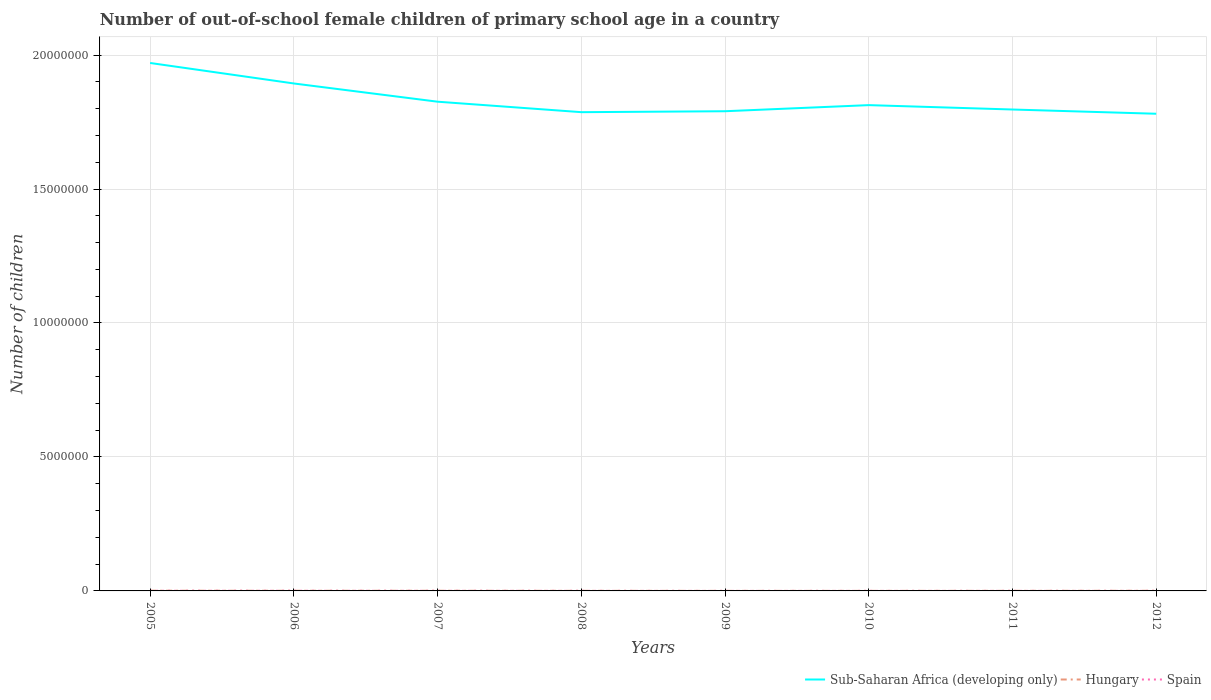How many different coloured lines are there?
Offer a very short reply. 3. Does the line corresponding to Sub-Saharan Africa (developing only) intersect with the line corresponding to Spain?
Your response must be concise. No. Is the number of lines equal to the number of legend labels?
Ensure brevity in your answer.  Yes. Across all years, what is the maximum number of out-of-school female children in Hungary?
Your answer should be very brief. 2098. In which year was the number of out-of-school female children in Spain maximum?
Your answer should be compact. 2009. What is the total number of out-of-school female children in Sub-Saharan Africa (developing only) in the graph?
Offer a very short reply. 1.28e+05. What is the difference between the highest and the second highest number of out-of-school female children in Spain?
Provide a succinct answer. 4768. What is the difference between the highest and the lowest number of out-of-school female children in Sub-Saharan Africa (developing only)?
Keep it short and to the point. 2. Is the number of out-of-school female children in Spain strictly greater than the number of out-of-school female children in Hungary over the years?
Keep it short and to the point. Yes. What is the difference between two consecutive major ticks on the Y-axis?
Your answer should be very brief. 5.00e+06. Are the values on the major ticks of Y-axis written in scientific E-notation?
Provide a succinct answer. No. Does the graph contain grids?
Your response must be concise. Yes. How are the legend labels stacked?
Offer a terse response. Horizontal. What is the title of the graph?
Provide a short and direct response. Number of out-of-school female children of primary school age in a country. What is the label or title of the X-axis?
Offer a very short reply. Years. What is the label or title of the Y-axis?
Provide a short and direct response. Number of children. What is the Number of children in Sub-Saharan Africa (developing only) in 2005?
Ensure brevity in your answer.  1.97e+07. What is the Number of children of Hungary in 2005?
Your response must be concise. 8210. What is the Number of children in Spain in 2005?
Offer a terse response. 5658. What is the Number of children in Sub-Saharan Africa (developing only) in 2006?
Give a very brief answer. 1.89e+07. What is the Number of children of Hungary in 2006?
Make the answer very short. 6465. What is the Number of children in Spain in 2006?
Give a very brief answer. 5814. What is the Number of children in Sub-Saharan Africa (developing only) in 2007?
Make the answer very short. 1.83e+07. What is the Number of children in Hungary in 2007?
Your answer should be very brief. 6589. What is the Number of children of Spain in 2007?
Your answer should be compact. 4183. What is the Number of children in Sub-Saharan Africa (developing only) in 2008?
Offer a terse response. 1.79e+07. What is the Number of children in Hungary in 2008?
Ensure brevity in your answer.  3879. What is the Number of children of Spain in 2008?
Your response must be concise. 2914. What is the Number of children in Sub-Saharan Africa (developing only) in 2009?
Provide a succinct answer. 1.79e+07. What is the Number of children in Hungary in 2009?
Your answer should be compact. 2098. What is the Number of children in Spain in 2009?
Your response must be concise. 1046. What is the Number of children in Sub-Saharan Africa (developing only) in 2010?
Give a very brief answer. 1.81e+07. What is the Number of children in Hungary in 2010?
Give a very brief answer. 2276. What is the Number of children in Spain in 2010?
Provide a short and direct response. 2010. What is the Number of children of Sub-Saharan Africa (developing only) in 2011?
Make the answer very short. 1.80e+07. What is the Number of children in Hungary in 2011?
Give a very brief answer. 3832. What is the Number of children of Spain in 2011?
Keep it short and to the point. 2020. What is the Number of children of Sub-Saharan Africa (developing only) in 2012?
Your response must be concise. 1.78e+07. What is the Number of children of Hungary in 2012?
Make the answer very short. 5886. What is the Number of children in Spain in 2012?
Provide a succinct answer. 1822. Across all years, what is the maximum Number of children of Sub-Saharan Africa (developing only)?
Offer a very short reply. 1.97e+07. Across all years, what is the maximum Number of children in Hungary?
Provide a succinct answer. 8210. Across all years, what is the maximum Number of children in Spain?
Offer a terse response. 5814. Across all years, what is the minimum Number of children in Sub-Saharan Africa (developing only)?
Offer a very short reply. 1.78e+07. Across all years, what is the minimum Number of children of Hungary?
Your answer should be compact. 2098. Across all years, what is the minimum Number of children of Spain?
Your answer should be compact. 1046. What is the total Number of children in Sub-Saharan Africa (developing only) in the graph?
Offer a terse response. 1.47e+08. What is the total Number of children in Hungary in the graph?
Your answer should be compact. 3.92e+04. What is the total Number of children in Spain in the graph?
Provide a succinct answer. 2.55e+04. What is the difference between the Number of children of Sub-Saharan Africa (developing only) in 2005 and that in 2006?
Give a very brief answer. 7.65e+05. What is the difference between the Number of children in Hungary in 2005 and that in 2006?
Your answer should be very brief. 1745. What is the difference between the Number of children in Spain in 2005 and that in 2006?
Make the answer very short. -156. What is the difference between the Number of children in Sub-Saharan Africa (developing only) in 2005 and that in 2007?
Provide a short and direct response. 1.45e+06. What is the difference between the Number of children in Hungary in 2005 and that in 2007?
Keep it short and to the point. 1621. What is the difference between the Number of children in Spain in 2005 and that in 2007?
Provide a succinct answer. 1475. What is the difference between the Number of children of Sub-Saharan Africa (developing only) in 2005 and that in 2008?
Give a very brief answer. 1.84e+06. What is the difference between the Number of children of Hungary in 2005 and that in 2008?
Your response must be concise. 4331. What is the difference between the Number of children in Spain in 2005 and that in 2008?
Your answer should be compact. 2744. What is the difference between the Number of children of Sub-Saharan Africa (developing only) in 2005 and that in 2009?
Your answer should be very brief. 1.80e+06. What is the difference between the Number of children of Hungary in 2005 and that in 2009?
Give a very brief answer. 6112. What is the difference between the Number of children of Spain in 2005 and that in 2009?
Make the answer very short. 4612. What is the difference between the Number of children of Sub-Saharan Africa (developing only) in 2005 and that in 2010?
Offer a very short reply. 1.57e+06. What is the difference between the Number of children in Hungary in 2005 and that in 2010?
Ensure brevity in your answer.  5934. What is the difference between the Number of children in Spain in 2005 and that in 2010?
Keep it short and to the point. 3648. What is the difference between the Number of children in Sub-Saharan Africa (developing only) in 2005 and that in 2011?
Offer a terse response. 1.74e+06. What is the difference between the Number of children of Hungary in 2005 and that in 2011?
Make the answer very short. 4378. What is the difference between the Number of children of Spain in 2005 and that in 2011?
Your response must be concise. 3638. What is the difference between the Number of children of Sub-Saharan Africa (developing only) in 2005 and that in 2012?
Offer a very short reply. 1.90e+06. What is the difference between the Number of children of Hungary in 2005 and that in 2012?
Offer a very short reply. 2324. What is the difference between the Number of children of Spain in 2005 and that in 2012?
Make the answer very short. 3836. What is the difference between the Number of children in Sub-Saharan Africa (developing only) in 2006 and that in 2007?
Offer a very short reply. 6.80e+05. What is the difference between the Number of children of Hungary in 2006 and that in 2007?
Keep it short and to the point. -124. What is the difference between the Number of children of Spain in 2006 and that in 2007?
Ensure brevity in your answer.  1631. What is the difference between the Number of children of Sub-Saharan Africa (developing only) in 2006 and that in 2008?
Give a very brief answer. 1.07e+06. What is the difference between the Number of children of Hungary in 2006 and that in 2008?
Your answer should be very brief. 2586. What is the difference between the Number of children of Spain in 2006 and that in 2008?
Give a very brief answer. 2900. What is the difference between the Number of children in Sub-Saharan Africa (developing only) in 2006 and that in 2009?
Offer a very short reply. 1.04e+06. What is the difference between the Number of children in Hungary in 2006 and that in 2009?
Provide a short and direct response. 4367. What is the difference between the Number of children in Spain in 2006 and that in 2009?
Your answer should be very brief. 4768. What is the difference between the Number of children of Sub-Saharan Africa (developing only) in 2006 and that in 2010?
Offer a terse response. 8.08e+05. What is the difference between the Number of children of Hungary in 2006 and that in 2010?
Provide a succinct answer. 4189. What is the difference between the Number of children of Spain in 2006 and that in 2010?
Provide a short and direct response. 3804. What is the difference between the Number of children of Sub-Saharan Africa (developing only) in 2006 and that in 2011?
Your answer should be very brief. 9.72e+05. What is the difference between the Number of children in Hungary in 2006 and that in 2011?
Ensure brevity in your answer.  2633. What is the difference between the Number of children of Spain in 2006 and that in 2011?
Your response must be concise. 3794. What is the difference between the Number of children in Sub-Saharan Africa (developing only) in 2006 and that in 2012?
Your response must be concise. 1.13e+06. What is the difference between the Number of children in Hungary in 2006 and that in 2012?
Keep it short and to the point. 579. What is the difference between the Number of children of Spain in 2006 and that in 2012?
Make the answer very short. 3992. What is the difference between the Number of children of Sub-Saharan Africa (developing only) in 2007 and that in 2008?
Your answer should be compact. 3.91e+05. What is the difference between the Number of children of Hungary in 2007 and that in 2008?
Give a very brief answer. 2710. What is the difference between the Number of children of Spain in 2007 and that in 2008?
Offer a very short reply. 1269. What is the difference between the Number of children of Sub-Saharan Africa (developing only) in 2007 and that in 2009?
Provide a succinct answer. 3.56e+05. What is the difference between the Number of children of Hungary in 2007 and that in 2009?
Your answer should be very brief. 4491. What is the difference between the Number of children of Spain in 2007 and that in 2009?
Give a very brief answer. 3137. What is the difference between the Number of children in Sub-Saharan Africa (developing only) in 2007 and that in 2010?
Keep it short and to the point. 1.28e+05. What is the difference between the Number of children of Hungary in 2007 and that in 2010?
Ensure brevity in your answer.  4313. What is the difference between the Number of children of Spain in 2007 and that in 2010?
Offer a very short reply. 2173. What is the difference between the Number of children in Sub-Saharan Africa (developing only) in 2007 and that in 2011?
Your answer should be compact. 2.92e+05. What is the difference between the Number of children in Hungary in 2007 and that in 2011?
Give a very brief answer. 2757. What is the difference between the Number of children in Spain in 2007 and that in 2011?
Keep it short and to the point. 2163. What is the difference between the Number of children in Sub-Saharan Africa (developing only) in 2007 and that in 2012?
Provide a succinct answer. 4.50e+05. What is the difference between the Number of children of Hungary in 2007 and that in 2012?
Provide a succinct answer. 703. What is the difference between the Number of children of Spain in 2007 and that in 2012?
Keep it short and to the point. 2361. What is the difference between the Number of children of Sub-Saharan Africa (developing only) in 2008 and that in 2009?
Ensure brevity in your answer.  -3.47e+04. What is the difference between the Number of children of Hungary in 2008 and that in 2009?
Offer a terse response. 1781. What is the difference between the Number of children of Spain in 2008 and that in 2009?
Keep it short and to the point. 1868. What is the difference between the Number of children of Sub-Saharan Africa (developing only) in 2008 and that in 2010?
Offer a terse response. -2.63e+05. What is the difference between the Number of children in Hungary in 2008 and that in 2010?
Your answer should be very brief. 1603. What is the difference between the Number of children of Spain in 2008 and that in 2010?
Your answer should be compact. 904. What is the difference between the Number of children in Sub-Saharan Africa (developing only) in 2008 and that in 2011?
Make the answer very short. -9.92e+04. What is the difference between the Number of children of Hungary in 2008 and that in 2011?
Ensure brevity in your answer.  47. What is the difference between the Number of children in Spain in 2008 and that in 2011?
Provide a succinct answer. 894. What is the difference between the Number of children of Sub-Saharan Africa (developing only) in 2008 and that in 2012?
Provide a succinct answer. 5.90e+04. What is the difference between the Number of children of Hungary in 2008 and that in 2012?
Provide a short and direct response. -2007. What is the difference between the Number of children of Spain in 2008 and that in 2012?
Your answer should be compact. 1092. What is the difference between the Number of children in Sub-Saharan Africa (developing only) in 2009 and that in 2010?
Give a very brief answer. -2.28e+05. What is the difference between the Number of children of Hungary in 2009 and that in 2010?
Your response must be concise. -178. What is the difference between the Number of children of Spain in 2009 and that in 2010?
Provide a short and direct response. -964. What is the difference between the Number of children of Sub-Saharan Africa (developing only) in 2009 and that in 2011?
Provide a short and direct response. -6.44e+04. What is the difference between the Number of children of Hungary in 2009 and that in 2011?
Keep it short and to the point. -1734. What is the difference between the Number of children of Spain in 2009 and that in 2011?
Your answer should be compact. -974. What is the difference between the Number of children of Sub-Saharan Africa (developing only) in 2009 and that in 2012?
Make the answer very short. 9.38e+04. What is the difference between the Number of children of Hungary in 2009 and that in 2012?
Offer a terse response. -3788. What is the difference between the Number of children in Spain in 2009 and that in 2012?
Provide a succinct answer. -776. What is the difference between the Number of children in Sub-Saharan Africa (developing only) in 2010 and that in 2011?
Keep it short and to the point. 1.64e+05. What is the difference between the Number of children in Hungary in 2010 and that in 2011?
Give a very brief answer. -1556. What is the difference between the Number of children in Spain in 2010 and that in 2011?
Offer a very short reply. -10. What is the difference between the Number of children in Sub-Saharan Africa (developing only) in 2010 and that in 2012?
Your answer should be very brief. 3.22e+05. What is the difference between the Number of children of Hungary in 2010 and that in 2012?
Your answer should be very brief. -3610. What is the difference between the Number of children of Spain in 2010 and that in 2012?
Give a very brief answer. 188. What is the difference between the Number of children in Sub-Saharan Africa (developing only) in 2011 and that in 2012?
Offer a very short reply. 1.58e+05. What is the difference between the Number of children in Hungary in 2011 and that in 2012?
Your answer should be compact. -2054. What is the difference between the Number of children of Spain in 2011 and that in 2012?
Your answer should be compact. 198. What is the difference between the Number of children in Sub-Saharan Africa (developing only) in 2005 and the Number of children in Hungary in 2006?
Provide a succinct answer. 1.97e+07. What is the difference between the Number of children in Sub-Saharan Africa (developing only) in 2005 and the Number of children in Spain in 2006?
Keep it short and to the point. 1.97e+07. What is the difference between the Number of children in Hungary in 2005 and the Number of children in Spain in 2006?
Provide a short and direct response. 2396. What is the difference between the Number of children of Sub-Saharan Africa (developing only) in 2005 and the Number of children of Hungary in 2007?
Ensure brevity in your answer.  1.97e+07. What is the difference between the Number of children in Sub-Saharan Africa (developing only) in 2005 and the Number of children in Spain in 2007?
Your answer should be very brief. 1.97e+07. What is the difference between the Number of children in Hungary in 2005 and the Number of children in Spain in 2007?
Offer a very short reply. 4027. What is the difference between the Number of children of Sub-Saharan Africa (developing only) in 2005 and the Number of children of Hungary in 2008?
Provide a succinct answer. 1.97e+07. What is the difference between the Number of children in Sub-Saharan Africa (developing only) in 2005 and the Number of children in Spain in 2008?
Provide a short and direct response. 1.97e+07. What is the difference between the Number of children of Hungary in 2005 and the Number of children of Spain in 2008?
Provide a short and direct response. 5296. What is the difference between the Number of children in Sub-Saharan Africa (developing only) in 2005 and the Number of children in Hungary in 2009?
Ensure brevity in your answer.  1.97e+07. What is the difference between the Number of children of Sub-Saharan Africa (developing only) in 2005 and the Number of children of Spain in 2009?
Give a very brief answer. 1.97e+07. What is the difference between the Number of children of Hungary in 2005 and the Number of children of Spain in 2009?
Offer a very short reply. 7164. What is the difference between the Number of children of Sub-Saharan Africa (developing only) in 2005 and the Number of children of Hungary in 2010?
Provide a succinct answer. 1.97e+07. What is the difference between the Number of children of Sub-Saharan Africa (developing only) in 2005 and the Number of children of Spain in 2010?
Your answer should be compact. 1.97e+07. What is the difference between the Number of children of Hungary in 2005 and the Number of children of Spain in 2010?
Provide a short and direct response. 6200. What is the difference between the Number of children of Sub-Saharan Africa (developing only) in 2005 and the Number of children of Hungary in 2011?
Your answer should be compact. 1.97e+07. What is the difference between the Number of children of Sub-Saharan Africa (developing only) in 2005 and the Number of children of Spain in 2011?
Keep it short and to the point. 1.97e+07. What is the difference between the Number of children in Hungary in 2005 and the Number of children in Spain in 2011?
Your answer should be very brief. 6190. What is the difference between the Number of children of Sub-Saharan Africa (developing only) in 2005 and the Number of children of Hungary in 2012?
Your answer should be compact. 1.97e+07. What is the difference between the Number of children in Sub-Saharan Africa (developing only) in 2005 and the Number of children in Spain in 2012?
Your answer should be compact. 1.97e+07. What is the difference between the Number of children in Hungary in 2005 and the Number of children in Spain in 2012?
Make the answer very short. 6388. What is the difference between the Number of children of Sub-Saharan Africa (developing only) in 2006 and the Number of children of Hungary in 2007?
Make the answer very short. 1.89e+07. What is the difference between the Number of children in Sub-Saharan Africa (developing only) in 2006 and the Number of children in Spain in 2007?
Keep it short and to the point. 1.89e+07. What is the difference between the Number of children of Hungary in 2006 and the Number of children of Spain in 2007?
Offer a very short reply. 2282. What is the difference between the Number of children in Sub-Saharan Africa (developing only) in 2006 and the Number of children in Hungary in 2008?
Make the answer very short. 1.89e+07. What is the difference between the Number of children in Sub-Saharan Africa (developing only) in 2006 and the Number of children in Spain in 2008?
Make the answer very short. 1.89e+07. What is the difference between the Number of children in Hungary in 2006 and the Number of children in Spain in 2008?
Make the answer very short. 3551. What is the difference between the Number of children in Sub-Saharan Africa (developing only) in 2006 and the Number of children in Hungary in 2009?
Offer a terse response. 1.89e+07. What is the difference between the Number of children in Sub-Saharan Africa (developing only) in 2006 and the Number of children in Spain in 2009?
Provide a succinct answer. 1.89e+07. What is the difference between the Number of children in Hungary in 2006 and the Number of children in Spain in 2009?
Offer a very short reply. 5419. What is the difference between the Number of children in Sub-Saharan Africa (developing only) in 2006 and the Number of children in Hungary in 2010?
Your response must be concise. 1.89e+07. What is the difference between the Number of children in Sub-Saharan Africa (developing only) in 2006 and the Number of children in Spain in 2010?
Provide a succinct answer. 1.89e+07. What is the difference between the Number of children in Hungary in 2006 and the Number of children in Spain in 2010?
Offer a terse response. 4455. What is the difference between the Number of children of Sub-Saharan Africa (developing only) in 2006 and the Number of children of Hungary in 2011?
Your response must be concise. 1.89e+07. What is the difference between the Number of children in Sub-Saharan Africa (developing only) in 2006 and the Number of children in Spain in 2011?
Provide a short and direct response. 1.89e+07. What is the difference between the Number of children in Hungary in 2006 and the Number of children in Spain in 2011?
Ensure brevity in your answer.  4445. What is the difference between the Number of children of Sub-Saharan Africa (developing only) in 2006 and the Number of children of Hungary in 2012?
Ensure brevity in your answer.  1.89e+07. What is the difference between the Number of children in Sub-Saharan Africa (developing only) in 2006 and the Number of children in Spain in 2012?
Your answer should be compact. 1.89e+07. What is the difference between the Number of children in Hungary in 2006 and the Number of children in Spain in 2012?
Make the answer very short. 4643. What is the difference between the Number of children in Sub-Saharan Africa (developing only) in 2007 and the Number of children in Hungary in 2008?
Make the answer very short. 1.83e+07. What is the difference between the Number of children of Sub-Saharan Africa (developing only) in 2007 and the Number of children of Spain in 2008?
Offer a very short reply. 1.83e+07. What is the difference between the Number of children of Hungary in 2007 and the Number of children of Spain in 2008?
Ensure brevity in your answer.  3675. What is the difference between the Number of children of Sub-Saharan Africa (developing only) in 2007 and the Number of children of Hungary in 2009?
Ensure brevity in your answer.  1.83e+07. What is the difference between the Number of children of Sub-Saharan Africa (developing only) in 2007 and the Number of children of Spain in 2009?
Your answer should be very brief. 1.83e+07. What is the difference between the Number of children of Hungary in 2007 and the Number of children of Spain in 2009?
Your answer should be compact. 5543. What is the difference between the Number of children in Sub-Saharan Africa (developing only) in 2007 and the Number of children in Hungary in 2010?
Your response must be concise. 1.83e+07. What is the difference between the Number of children in Sub-Saharan Africa (developing only) in 2007 and the Number of children in Spain in 2010?
Offer a very short reply. 1.83e+07. What is the difference between the Number of children in Hungary in 2007 and the Number of children in Spain in 2010?
Give a very brief answer. 4579. What is the difference between the Number of children in Sub-Saharan Africa (developing only) in 2007 and the Number of children in Hungary in 2011?
Provide a succinct answer. 1.83e+07. What is the difference between the Number of children of Sub-Saharan Africa (developing only) in 2007 and the Number of children of Spain in 2011?
Make the answer very short. 1.83e+07. What is the difference between the Number of children in Hungary in 2007 and the Number of children in Spain in 2011?
Provide a succinct answer. 4569. What is the difference between the Number of children in Sub-Saharan Africa (developing only) in 2007 and the Number of children in Hungary in 2012?
Your answer should be compact. 1.83e+07. What is the difference between the Number of children in Sub-Saharan Africa (developing only) in 2007 and the Number of children in Spain in 2012?
Offer a terse response. 1.83e+07. What is the difference between the Number of children of Hungary in 2007 and the Number of children of Spain in 2012?
Provide a succinct answer. 4767. What is the difference between the Number of children of Sub-Saharan Africa (developing only) in 2008 and the Number of children of Hungary in 2009?
Keep it short and to the point. 1.79e+07. What is the difference between the Number of children in Sub-Saharan Africa (developing only) in 2008 and the Number of children in Spain in 2009?
Offer a terse response. 1.79e+07. What is the difference between the Number of children in Hungary in 2008 and the Number of children in Spain in 2009?
Give a very brief answer. 2833. What is the difference between the Number of children of Sub-Saharan Africa (developing only) in 2008 and the Number of children of Hungary in 2010?
Your response must be concise. 1.79e+07. What is the difference between the Number of children in Sub-Saharan Africa (developing only) in 2008 and the Number of children in Spain in 2010?
Keep it short and to the point. 1.79e+07. What is the difference between the Number of children of Hungary in 2008 and the Number of children of Spain in 2010?
Provide a short and direct response. 1869. What is the difference between the Number of children in Sub-Saharan Africa (developing only) in 2008 and the Number of children in Hungary in 2011?
Provide a short and direct response. 1.79e+07. What is the difference between the Number of children of Sub-Saharan Africa (developing only) in 2008 and the Number of children of Spain in 2011?
Make the answer very short. 1.79e+07. What is the difference between the Number of children in Hungary in 2008 and the Number of children in Spain in 2011?
Provide a succinct answer. 1859. What is the difference between the Number of children of Sub-Saharan Africa (developing only) in 2008 and the Number of children of Hungary in 2012?
Provide a short and direct response. 1.79e+07. What is the difference between the Number of children of Sub-Saharan Africa (developing only) in 2008 and the Number of children of Spain in 2012?
Provide a succinct answer. 1.79e+07. What is the difference between the Number of children in Hungary in 2008 and the Number of children in Spain in 2012?
Keep it short and to the point. 2057. What is the difference between the Number of children of Sub-Saharan Africa (developing only) in 2009 and the Number of children of Hungary in 2010?
Provide a succinct answer. 1.79e+07. What is the difference between the Number of children in Sub-Saharan Africa (developing only) in 2009 and the Number of children in Spain in 2010?
Offer a very short reply. 1.79e+07. What is the difference between the Number of children in Hungary in 2009 and the Number of children in Spain in 2010?
Your answer should be compact. 88. What is the difference between the Number of children in Sub-Saharan Africa (developing only) in 2009 and the Number of children in Hungary in 2011?
Give a very brief answer. 1.79e+07. What is the difference between the Number of children in Sub-Saharan Africa (developing only) in 2009 and the Number of children in Spain in 2011?
Provide a short and direct response. 1.79e+07. What is the difference between the Number of children of Hungary in 2009 and the Number of children of Spain in 2011?
Provide a succinct answer. 78. What is the difference between the Number of children of Sub-Saharan Africa (developing only) in 2009 and the Number of children of Hungary in 2012?
Keep it short and to the point. 1.79e+07. What is the difference between the Number of children of Sub-Saharan Africa (developing only) in 2009 and the Number of children of Spain in 2012?
Keep it short and to the point. 1.79e+07. What is the difference between the Number of children of Hungary in 2009 and the Number of children of Spain in 2012?
Offer a very short reply. 276. What is the difference between the Number of children in Sub-Saharan Africa (developing only) in 2010 and the Number of children in Hungary in 2011?
Provide a succinct answer. 1.81e+07. What is the difference between the Number of children of Sub-Saharan Africa (developing only) in 2010 and the Number of children of Spain in 2011?
Give a very brief answer. 1.81e+07. What is the difference between the Number of children of Hungary in 2010 and the Number of children of Spain in 2011?
Offer a very short reply. 256. What is the difference between the Number of children in Sub-Saharan Africa (developing only) in 2010 and the Number of children in Hungary in 2012?
Give a very brief answer. 1.81e+07. What is the difference between the Number of children of Sub-Saharan Africa (developing only) in 2010 and the Number of children of Spain in 2012?
Provide a short and direct response. 1.81e+07. What is the difference between the Number of children in Hungary in 2010 and the Number of children in Spain in 2012?
Provide a succinct answer. 454. What is the difference between the Number of children in Sub-Saharan Africa (developing only) in 2011 and the Number of children in Hungary in 2012?
Provide a short and direct response. 1.80e+07. What is the difference between the Number of children of Sub-Saharan Africa (developing only) in 2011 and the Number of children of Spain in 2012?
Your answer should be compact. 1.80e+07. What is the difference between the Number of children in Hungary in 2011 and the Number of children in Spain in 2012?
Your answer should be compact. 2010. What is the average Number of children of Sub-Saharan Africa (developing only) per year?
Offer a terse response. 1.83e+07. What is the average Number of children in Hungary per year?
Your answer should be compact. 4904.38. What is the average Number of children of Spain per year?
Your answer should be compact. 3183.38. In the year 2005, what is the difference between the Number of children of Sub-Saharan Africa (developing only) and Number of children of Hungary?
Keep it short and to the point. 1.97e+07. In the year 2005, what is the difference between the Number of children in Sub-Saharan Africa (developing only) and Number of children in Spain?
Keep it short and to the point. 1.97e+07. In the year 2005, what is the difference between the Number of children in Hungary and Number of children in Spain?
Your answer should be compact. 2552. In the year 2006, what is the difference between the Number of children of Sub-Saharan Africa (developing only) and Number of children of Hungary?
Offer a very short reply. 1.89e+07. In the year 2006, what is the difference between the Number of children in Sub-Saharan Africa (developing only) and Number of children in Spain?
Ensure brevity in your answer.  1.89e+07. In the year 2006, what is the difference between the Number of children in Hungary and Number of children in Spain?
Keep it short and to the point. 651. In the year 2007, what is the difference between the Number of children in Sub-Saharan Africa (developing only) and Number of children in Hungary?
Your answer should be very brief. 1.83e+07. In the year 2007, what is the difference between the Number of children in Sub-Saharan Africa (developing only) and Number of children in Spain?
Ensure brevity in your answer.  1.83e+07. In the year 2007, what is the difference between the Number of children of Hungary and Number of children of Spain?
Ensure brevity in your answer.  2406. In the year 2008, what is the difference between the Number of children in Sub-Saharan Africa (developing only) and Number of children in Hungary?
Provide a succinct answer. 1.79e+07. In the year 2008, what is the difference between the Number of children in Sub-Saharan Africa (developing only) and Number of children in Spain?
Provide a succinct answer. 1.79e+07. In the year 2008, what is the difference between the Number of children of Hungary and Number of children of Spain?
Make the answer very short. 965. In the year 2009, what is the difference between the Number of children of Sub-Saharan Africa (developing only) and Number of children of Hungary?
Offer a very short reply. 1.79e+07. In the year 2009, what is the difference between the Number of children of Sub-Saharan Africa (developing only) and Number of children of Spain?
Offer a terse response. 1.79e+07. In the year 2009, what is the difference between the Number of children in Hungary and Number of children in Spain?
Keep it short and to the point. 1052. In the year 2010, what is the difference between the Number of children in Sub-Saharan Africa (developing only) and Number of children in Hungary?
Offer a very short reply. 1.81e+07. In the year 2010, what is the difference between the Number of children of Sub-Saharan Africa (developing only) and Number of children of Spain?
Keep it short and to the point. 1.81e+07. In the year 2010, what is the difference between the Number of children of Hungary and Number of children of Spain?
Your response must be concise. 266. In the year 2011, what is the difference between the Number of children in Sub-Saharan Africa (developing only) and Number of children in Hungary?
Offer a terse response. 1.80e+07. In the year 2011, what is the difference between the Number of children of Sub-Saharan Africa (developing only) and Number of children of Spain?
Keep it short and to the point. 1.80e+07. In the year 2011, what is the difference between the Number of children in Hungary and Number of children in Spain?
Your answer should be very brief. 1812. In the year 2012, what is the difference between the Number of children of Sub-Saharan Africa (developing only) and Number of children of Hungary?
Give a very brief answer. 1.78e+07. In the year 2012, what is the difference between the Number of children in Sub-Saharan Africa (developing only) and Number of children in Spain?
Your answer should be very brief. 1.78e+07. In the year 2012, what is the difference between the Number of children of Hungary and Number of children of Spain?
Your answer should be compact. 4064. What is the ratio of the Number of children in Sub-Saharan Africa (developing only) in 2005 to that in 2006?
Ensure brevity in your answer.  1.04. What is the ratio of the Number of children in Hungary in 2005 to that in 2006?
Offer a terse response. 1.27. What is the ratio of the Number of children of Spain in 2005 to that in 2006?
Your answer should be very brief. 0.97. What is the ratio of the Number of children in Sub-Saharan Africa (developing only) in 2005 to that in 2007?
Ensure brevity in your answer.  1.08. What is the ratio of the Number of children of Hungary in 2005 to that in 2007?
Your response must be concise. 1.25. What is the ratio of the Number of children of Spain in 2005 to that in 2007?
Your answer should be compact. 1.35. What is the ratio of the Number of children in Sub-Saharan Africa (developing only) in 2005 to that in 2008?
Ensure brevity in your answer.  1.1. What is the ratio of the Number of children in Hungary in 2005 to that in 2008?
Offer a very short reply. 2.12. What is the ratio of the Number of children in Spain in 2005 to that in 2008?
Offer a very short reply. 1.94. What is the ratio of the Number of children in Sub-Saharan Africa (developing only) in 2005 to that in 2009?
Your answer should be compact. 1.1. What is the ratio of the Number of children of Hungary in 2005 to that in 2009?
Provide a short and direct response. 3.91. What is the ratio of the Number of children in Spain in 2005 to that in 2009?
Your answer should be compact. 5.41. What is the ratio of the Number of children of Sub-Saharan Africa (developing only) in 2005 to that in 2010?
Your answer should be compact. 1.09. What is the ratio of the Number of children in Hungary in 2005 to that in 2010?
Offer a very short reply. 3.61. What is the ratio of the Number of children in Spain in 2005 to that in 2010?
Ensure brevity in your answer.  2.81. What is the ratio of the Number of children of Sub-Saharan Africa (developing only) in 2005 to that in 2011?
Offer a very short reply. 1.1. What is the ratio of the Number of children of Hungary in 2005 to that in 2011?
Your answer should be compact. 2.14. What is the ratio of the Number of children in Spain in 2005 to that in 2011?
Keep it short and to the point. 2.8. What is the ratio of the Number of children in Sub-Saharan Africa (developing only) in 2005 to that in 2012?
Ensure brevity in your answer.  1.11. What is the ratio of the Number of children of Hungary in 2005 to that in 2012?
Your response must be concise. 1.39. What is the ratio of the Number of children of Spain in 2005 to that in 2012?
Your answer should be very brief. 3.11. What is the ratio of the Number of children in Sub-Saharan Africa (developing only) in 2006 to that in 2007?
Your response must be concise. 1.04. What is the ratio of the Number of children of Hungary in 2006 to that in 2007?
Ensure brevity in your answer.  0.98. What is the ratio of the Number of children of Spain in 2006 to that in 2007?
Keep it short and to the point. 1.39. What is the ratio of the Number of children of Sub-Saharan Africa (developing only) in 2006 to that in 2008?
Provide a succinct answer. 1.06. What is the ratio of the Number of children of Hungary in 2006 to that in 2008?
Your answer should be compact. 1.67. What is the ratio of the Number of children in Spain in 2006 to that in 2008?
Keep it short and to the point. 2. What is the ratio of the Number of children in Sub-Saharan Africa (developing only) in 2006 to that in 2009?
Your response must be concise. 1.06. What is the ratio of the Number of children of Hungary in 2006 to that in 2009?
Give a very brief answer. 3.08. What is the ratio of the Number of children in Spain in 2006 to that in 2009?
Provide a succinct answer. 5.56. What is the ratio of the Number of children of Sub-Saharan Africa (developing only) in 2006 to that in 2010?
Offer a very short reply. 1.04. What is the ratio of the Number of children in Hungary in 2006 to that in 2010?
Offer a terse response. 2.84. What is the ratio of the Number of children in Spain in 2006 to that in 2010?
Keep it short and to the point. 2.89. What is the ratio of the Number of children in Sub-Saharan Africa (developing only) in 2006 to that in 2011?
Offer a very short reply. 1.05. What is the ratio of the Number of children of Hungary in 2006 to that in 2011?
Ensure brevity in your answer.  1.69. What is the ratio of the Number of children of Spain in 2006 to that in 2011?
Offer a terse response. 2.88. What is the ratio of the Number of children of Sub-Saharan Africa (developing only) in 2006 to that in 2012?
Provide a short and direct response. 1.06. What is the ratio of the Number of children of Hungary in 2006 to that in 2012?
Ensure brevity in your answer.  1.1. What is the ratio of the Number of children in Spain in 2006 to that in 2012?
Your answer should be compact. 3.19. What is the ratio of the Number of children in Sub-Saharan Africa (developing only) in 2007 to that in 2008?
Your answer should be compact. 1.02. What is the ratio of the Number of children in Hungary in 2007 to that in 2008?
Offer a terse response. 1.7. What is the ratio of the Number of children of Spain in 2007 to that in 2008?
Make the answer very short. 1.44. What is the ratio of the Number of children in Sub-Saharan Africa (developing only) in 2007 to that in 2009?
Provide a short and direct response. 1.02. What is the ratio of the Number of children in Hungary in 2007 to that in 2009?
Ensure brevity in your answer.  3.14. What is the ratio of the Number of children in Spain in 2007 to that in 2009?
Your response must be concise. 4. What is the ratio of the Number of children in Sub-Saharan Africa (developing only) in 2007 to that in 2010?
Offer a terse response. 1.01. What is the ratio of the Number of children in Hungary in 2007 to that in 2010?
Keep it short and to the point. 2.9. What is the ratio of the Number of children in Spain in 2007 to that in 2010?
Offer a very short reply. 2.08. What is the ratio of the Number of children in Sub-Saharan Africa (developing only) in 2007 to that in 2011?
Your answer should be compact. 1.02. What is the ratio of the Number of children of Hungary in 2007 to that in 2011?
Offer a very short reply. 1.72. What is the ratio of the Number of children in Spain in 2007 to that in 2011?
Make the answer very short. 2.07. What is the ratio of the Number of children in Sub-Saharan Africa (developing only) in 2007 to that in 2012?
Offer a terse response. 1.03. What is the ratio of the Number of children of Hungary in 2007 to that in 2012?
Your response must be concise. 1.12. What is the ratio of the Number of children in Spain in 2007 to that in 2012?
Offer a very short reply. 2.3. What is the ratio of the Number of children in Hungary in 2008 to that in 2009?
Your answer should be very brief. 1.85. What is the ratio of the Number of children of Spain in 2008 to that in 2009?
Your answer should be very brief. 2.79. What is the ratio of the Number of children in Sub-Saharan Africa (developing only) in 2008 to that in 2010?
Make the answer very short. 0.99. What is the ratio of the Number of children of Hungary in 2008 to that in 2010?
Your response must be concise. 1.7. What is the ratio of the Number of children in Spain in 2008 to that in 2010?
Offer a very short reply. 1.45. What is the ratio of the Number of children in Sub-Saharan Africa (developing only) in 2008 to that in 2011?
Make the answer very short. 0.99. What is the ratio of the Number of children of Hungary in 2008 to that in 2011?
Offer a terse response. 1.01. What is the ratio of the Number of children of Spain in 2008 to that in 2011?
Keep it short and to the point. 1.44. What is the ratio of the Number of children in Sub-Saharan Africa (developing only) in 2008 to that in 2012?
Your answer should be very brief. 1. What is the ratio of the Number of children of Hungary in 2008 to that in 2012?
Your answer should be very brief. 0.66. What is the ratio of the Number of children of Spain in 2008 to that in 2012?
Keep it short and to the point. 1.6. What is the ratio of the Number of children in Sub-Saharan Africa (developing only) in 2009 to that in 2010?
Give a very brief answer. 0.99. What is the ratio of the Number of children of Hungary in 2009 to that in 2010?
Provide a short and direct response. 0.92. What is the ratio of the Number of children of Spain in 2009 to that in 2010?
Provide a short and direct response. 0.52. What is the ratio of the Number of children of Hungary in 2009 to that in 2011?
Your response must be concise. 0.55. What is the ratio of the Number of children of Spain in 2009 to that in 2011?
Your answer should be compact. 0.52. What is the ratio of the Number of children in Sub-Saharan Africa (developing only) in 2009 to that in 2012?
Ensure brevity in your answer.  1.01. What is the ratio of the Number of children in Hungary in 2009 to that in 2012?
Your response must be concise. 0.36. What is the ratio of the Number of children of Spain in 2009 to that in 2012?
Provide a succinct answer. 0.57. What is the ratio of the Number of children in Sub-Saharan Africa (developing only) in 2010 to that in 2011?
Offer a very short reply. 1.01. What is the ratio of the Number of children of Hungary in 2010 to that in 2011?
Provide a succinct answer. 0.59. What is the ratio of the Number of children in Spain in 2010 to that in 2011?
Make the answer very short. 0.99. What is the ratio of the Number of children in Sub-Saharan Africa (developing only) in 2010 to that in 2012?
Your answer should be compact. 1.02. What is the ratio of the Number of children of Hungary in 2010 to that in 2012?
Provide a short and direct response. 0.39. What is the ratio of the Number of children in Spain in 2010 to that in 2012?
Your answer should be compact. 1.1. What is the ratio of the Number of children in Sub-Saharan Africa (developing only) in 2011 to that in 2012?
Offer a very short reply. 1.01. What is the ratio of the Number of children in Hungary in 2011 to that in 2012?
Make the answer very short. 0.65. What is the ratio of the Number of children in Spain in 2011 to that in 2012?
Ensure brevity in your answer.  1.11. What is the difference between the highest and the second highest Number of children in Sub-Saharan Africa (developing only)?
Offer a terse response. 7.65e+05. What is the difference between the highest and the second highest Number of children of Hungary?
Provide a succinct answer. 1621. What is the difference between the highest and the second highest Number of children of Spain?
Ensure brevity in your answer.  156. What is the difference between the highest and the lowest Number of children in Sub-Saharan Africa (developing only)?
Provide a succinct answer. 1.90e+06. What is the difference between the highest and the lowest Number of children of Hungary?
Provide a short and direct response. 6112. What is the difference between the highest and the lowest Number of children in Spain?
Your answer should be very brief. 4768. 